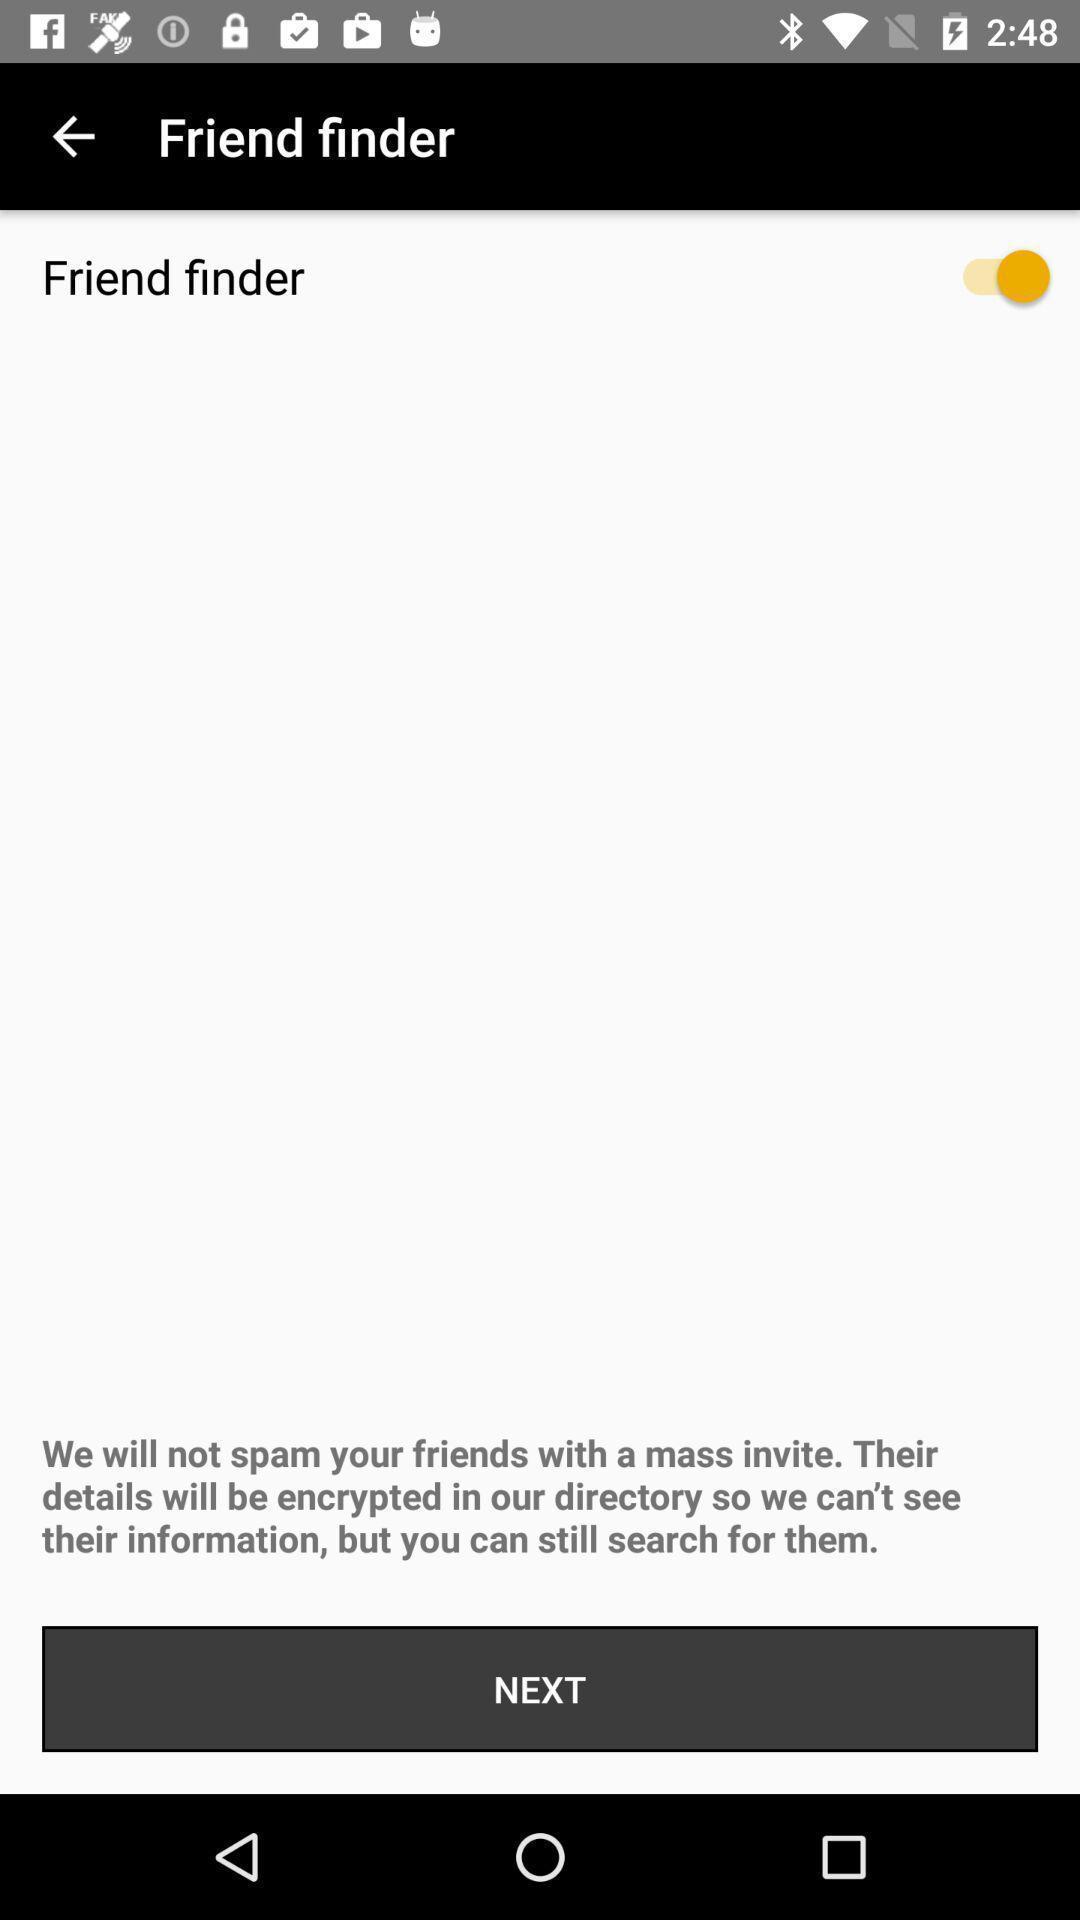Summarize the main components in this picture. Screen displaying friend finder page. 